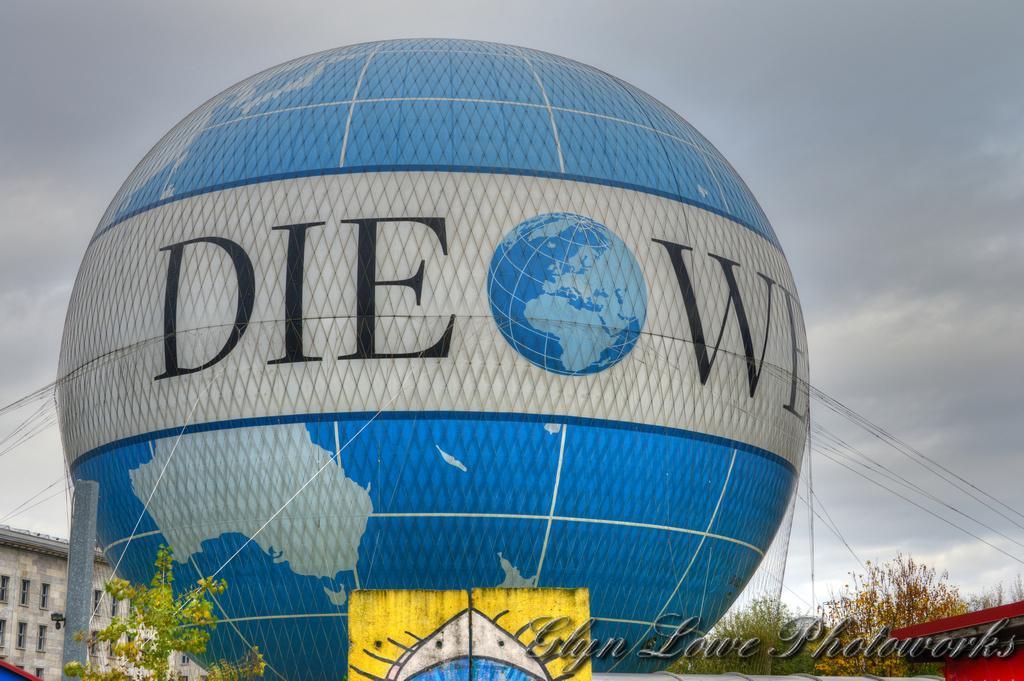Describe this image in one or two sentences. In this picture we can see a gas balloon, ropes, trees, building with windows, some objects and in the background we can see the sky. At the bottom right corner of this picture we can see some text. 